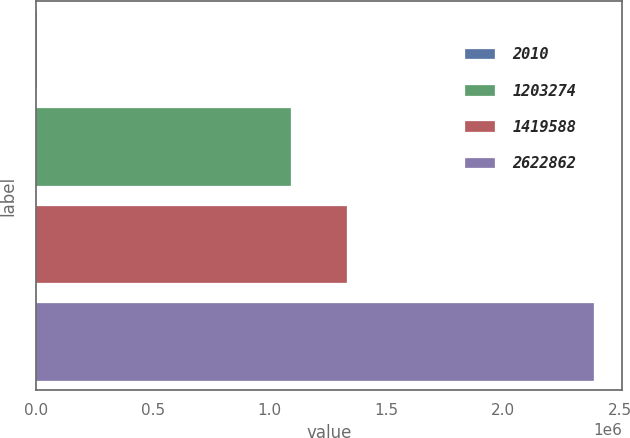<chart> <loc_0><loc_0><loc_500><loc_500><bar_chart><fcel>2010<fcel>1203274<fcel>1419588<fcel>2622862<nl><fcel>2008<fcel>1.09254e+06<fcel>1.33128e+06<fcel>2.38937e+06<nl></chart> 